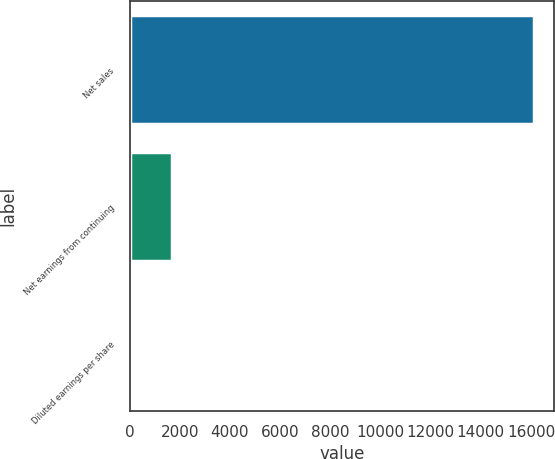<chart> <loc_0><loc_0><loc_500><loc_500><bar_chart><fcel>Net sales<fcel>Net earnings from continuing<fcel>Diluted earnings per share<nl><fcel>16112<fcel>1692<fcel>2.62<nl></chart> 